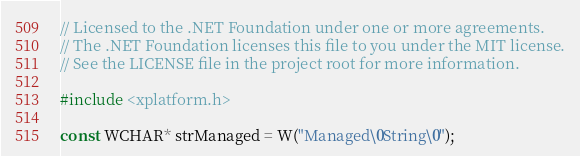Convert code to text. <code><loc_0><loc_0><loc_500><loc_500><_C++_>// Licensed to the .NET Foundation under one or more agreements.
// The .NET Foundation licenses this file to you under the MIT license.
// See the LICENSE file in the project root for more information.

#include <xplatform.h>

const WCHAR* strManaged = W("Managed\0String\0");</code> 